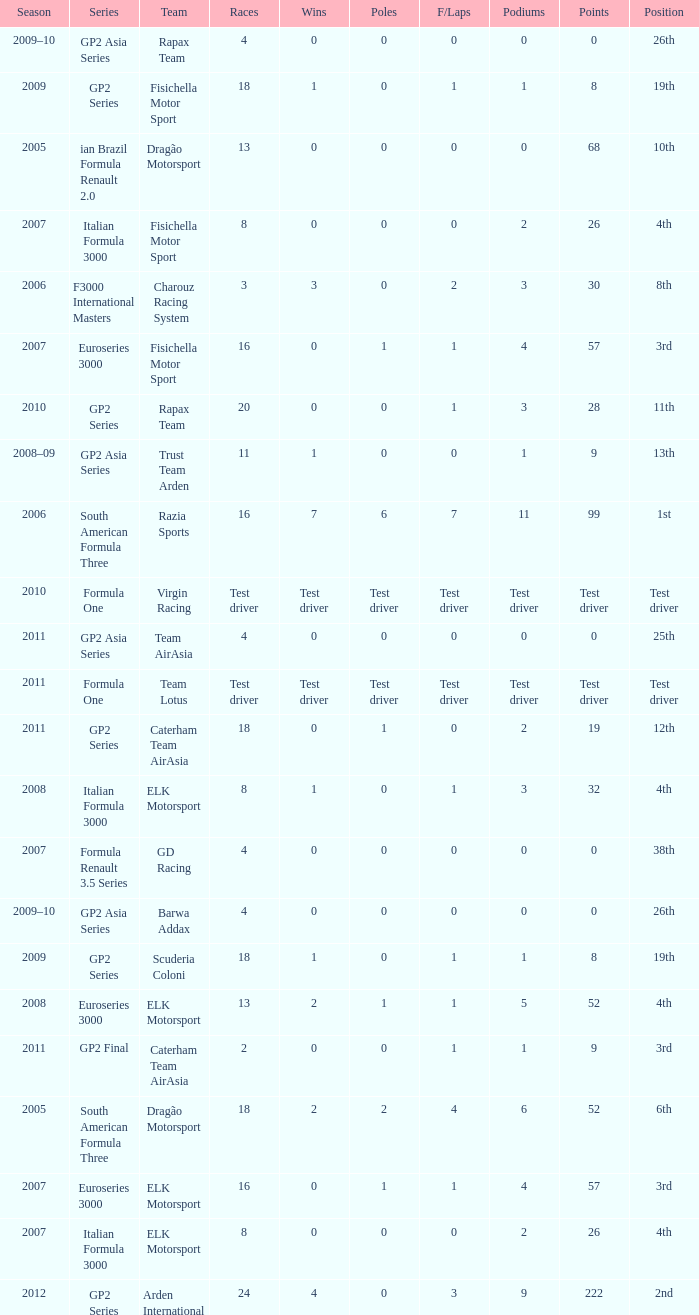What were the points in the year when his Podiums were 5? 52.0. 